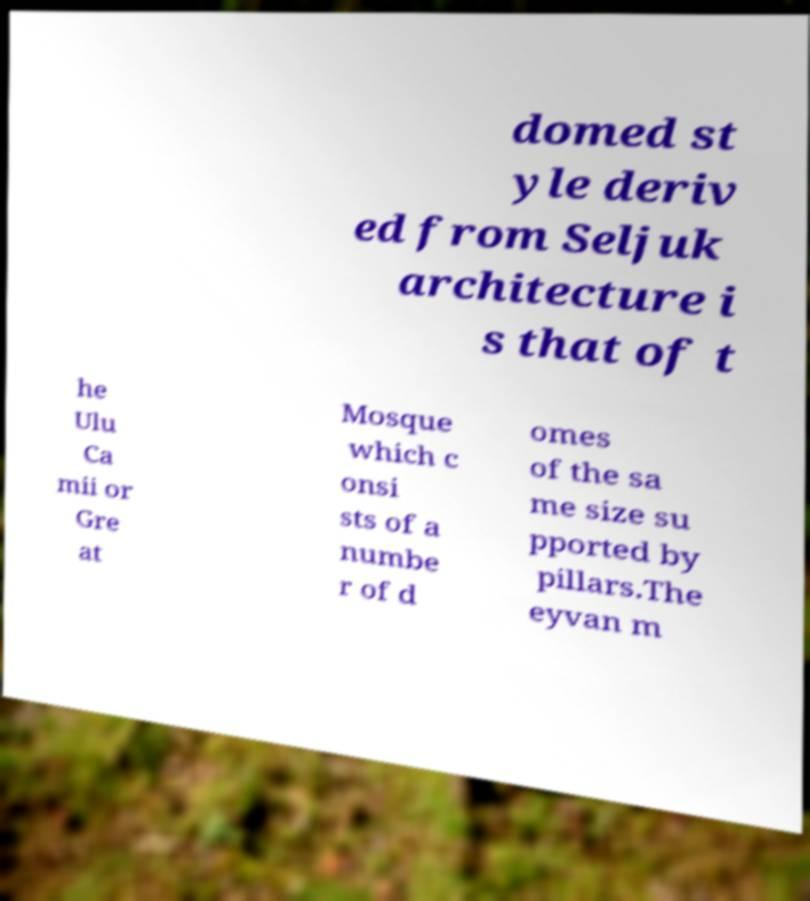Could you extract and type out the text from this image? domed st yle deriv ed from Seljuk architecture i s that of t he Ulu Ca mii or Gre at Mosque which c onsi sts of a numbe r of d omes of the sa me size su pported by pillars.The eyvan m 